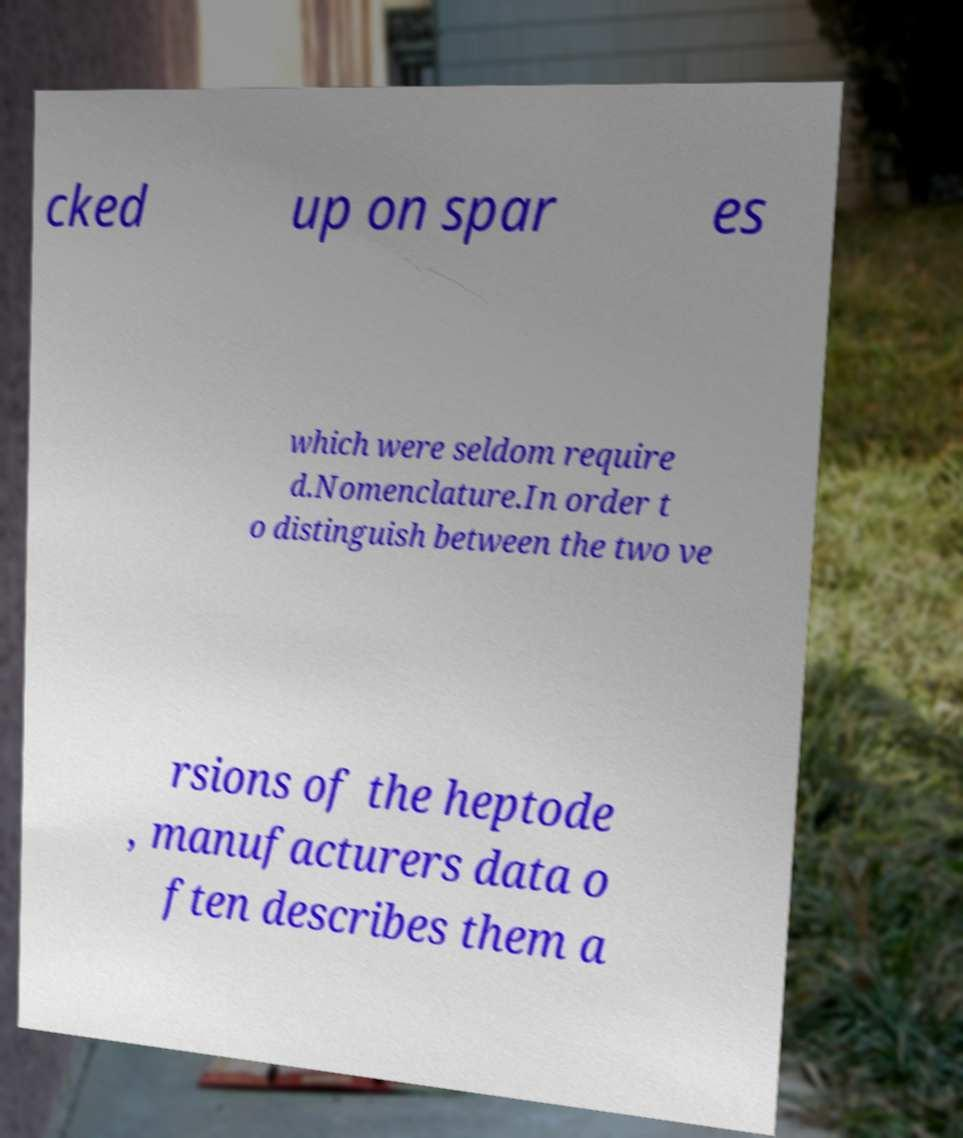For documentation purposes, I need the text within this image transcribed. Could you provide that? cked up on spar es which were seldom require d.Nomenclature.In order t o distinguish between the two ve rsions of the heptode , manufacturers data o ften describes them a 